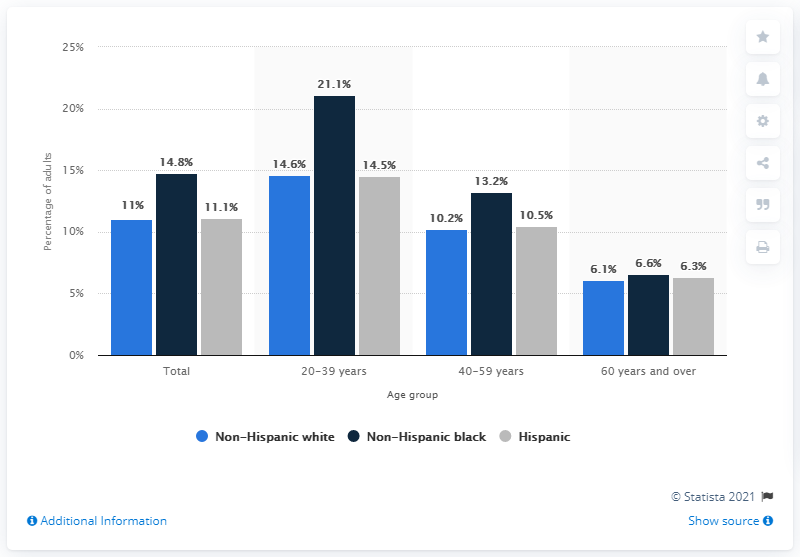Give some essential details in this illustration. During the years 2007 to 2010, non-Hispanic black individuals consumed a total of 21.1 percent of their daily caloric intake from food and beverages. 